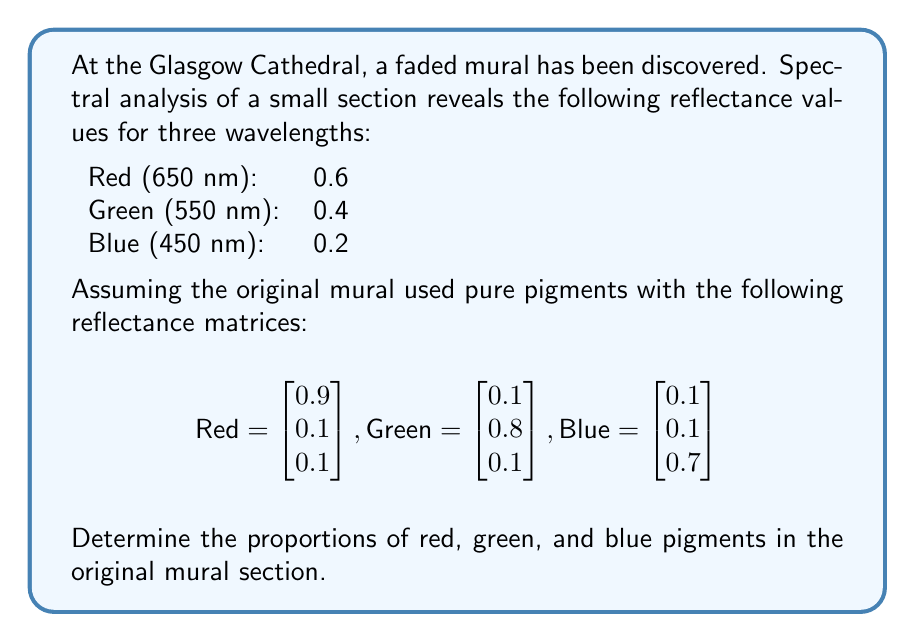Could you help me with this problem? To solve this inverse problem, we need to find the original pigment proportions that resulted in the observed reflectance values. Let's approach this step-by-step:

1) Let $x$, $y$, and $z$ represent the proportions of red, green, and blue pigments respectively.

2) We can set up a system of linear equations based on the observed reflectance values and the known pigment reflectance matrices:

   $$0.9x + 0.1y + 0.1z = 0.6$$
   $$0.1x + 0.8y + 0.1z = 0.4$$
   $$0.1x + 0.1y + 0.7z = 0.2$$

3) This can be represented in matrix form as $A\vec{v} = \vec{b}$:

   $$\begin{bmatrix}
   0.9 & 0.1 & 0.1 \\
   0.1 & 0.8 & 0.1 \\
   0.1 & 0.1 & 0.7
   \end{bmatrix}
   \begin{bmatrix} x \\ y \\ z \end{bmatrix} =
   \begin{bmatrix} 0.6 \\ 0.4 \\ 0.2 \end{bmatrix}$$

4) To solve this, we can use the inverse matrix method: $\vec{v} = A^{-1}\vec{b}$

5) Calculate the inverse of matrix $A$:

   $$A^{-1} = \begin{bmatrix}
   1.1494 & -0.1724 & -0.0115 \\
   -0.1724 & 1.2644 & -0.1034 \\
   -0.0115 & -0.1034 & 1.4368
   \end{bmatrix}$$

6) Multiply $A^{-1}$ by $\vec{b}$:

   $$\begin{bmatrix} x \\ y \\ z \end{bmatrix} =
   \begin{bmatrix}
   1.1494 & -0.1724 & -0.0115 \\
   -0.1724 & 1.2644 & -0.1034 \\
   -0.0115 & -0.1034 & 1.4368
   \end{bmatrix}
   \begin{bmatrix} 0.6 \\ 0.4 \\ 0.2 \end{bmatrix}$$

7) Calculating this gives us:

   $$\begin{bmatrix} x \\ y \\ z \end{bmatrix} =
   \begin{bmatrix} 0.6 \\ 0.4 \\ 0.2 \end{bmatrix}$$

Therefore, the original proportions of red, green, and blue pigments were 0.6, 0.4, and 0.2 respectively.
Answer: Red: 0.6, Green: 0.4, Blue: 0.2 